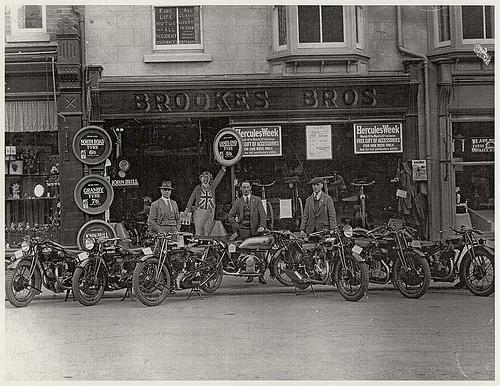Provide a brief analysis of the object interactions in the image. The motorcycles are parked close together, facing the store, the men are interacting with the bikes by standing behind them, and the signage on the store is placed to attract attention. Explain the connection between the men and the motorcycles. The men are possibly the owners of Brookes Bros store or customers, standing behind the motorcycles, which are likely for sale or display. Explain any indications of the time period or location in the image. The black and white photo, old motorcycles, and vintage clothing on the men suggest an older time period, possibly mid-20th century. The British flag shirt on one man indicates the location could be England. Describe the appearances of the three men in the image. The three men include an owner dressed in a suit and hat, a man wearing a shirt with the British flag, and a cardboard figure of man raising his arm holding up a sign. Count the number of motorcycles and describe their placement in the image. There are 7 motorcycles, parked on the side of the road and backed up against the curb, some on the sidewalk and some in the street. What type of building is prominent in the image and provide some details about it? The prominent building is Brookes Bros store, a motorbike store with a large sign, several advertisements and windows above the storefront. Explain the sentiment or atmosphere depicted in the image. The atmosphere is nostalgic and historic, as the image is black and white, showing old motorcycles, and men in vintage clothing outside an old store. Identify the primary focus of the image and give a brief description of the scene. The main focus is on a group of old motorcycles parked in front of the Brookes Bros store, with three men standing nearby, and several signs and details on the building. Identify and describe any advertising-related elements in the image. There are several advertisements, including a "Hercules Week" sign, a "Grandby Tire" sign, circular-shaped signs, and an "X" on the building. Describe any unique features or designs the motorcycles have. The motorcycles have large lights on the front, wheels, and are parked on kickstands. They are older models and appear to be in good condition. Identify a possible connection between the store and the motorcycles on display. The store, Brookes Bros, might be selling the old motorcycles displayed in front of it. Determine the main event occurring in this scene. Motorcycles being displayed in front of the store Describe the man with the flag shirt. Wearing an England's flag shirt, has arm raised Describe the scene in front of the store using the available captions. Old motorcycles parked, men standing behind motorcycles, motorcycles on the road, motorcycles on display, lined up in front of the store, with British flag shirt man. Identify and describe an object in the photo that represents the country of England. The man's shirt featuring the British flag Is there a sign advertising Coca-Cola among the signage on the building? There are signs mentioned, such as Hercules Week and Grandby Tire, but there is no information about a Coca-Cola sign. Are the motorcycles all red-colored? The image is black and white, which means it is impossible to infer any color for the objects present. In the scene, determine the number of motorcycles that are parked together. Seven motorcycles parked together Layout a sequence of activities using the available captions. Men standing outside the shop, old motorcycles lined up on the street and sidewalk, three owners of the store gathered together Identify the type of photograph depicted in the captions. A black and white picture Based on the available information, explain the layout of the shop and its elements. The shop has shelves next to it, bicycles inside, large windows above the store, circle-shaped signs, and a cardboard figure holding up a sign. Spot the sign that has the name of the building and share its content. Brookes Bros What is the color of the photo? Option B: Silver and Black Can you see any modern electric scooters among the motorcycles? The information mentions old motorcycles, not modern electric scooters. The focus is on the older bikes, which suggests that there are no electric scooters in the image. What is the position of the motorcycles in the scene? Lined up on the street and sidewalk What are the men doing in this scenario? Standing behind motorcycles Find the sign that mentions a specific week, and provide its content. Hercules Week Analyze the sign in the window and determine its shape. Circle shaped Provide a detailed observation of a particular man in the image based on the available information. A man wearing an England's flag shirt with his arm raised Do you notice several cars parked behind the motorcycles? There is no mention of cars in the given information, only motorcycles are mentioned being parked. Create a sentence using the details provided in the captions about the men in the scene. Three men stand together outside of the Brookes Bros store, one of them wearing a British flag shirt and another one dressed in a suit and hat. Can you see a group of five women standing in front of the store? There is no information about a group of five women standing in front of the store. The given information only mentions three men standing in front of Brookes Bros store. Is there a sign on the store saying "Apple Store"? There is no mention of an Apple Store in the given information. The store name is Brookes Bros, not Apple Store. Using the available captions, provide a brief description of the motorcycles. Older motorcycles with large lights on the front, parked in front of the store, on the side of the road, and on kickstands. 